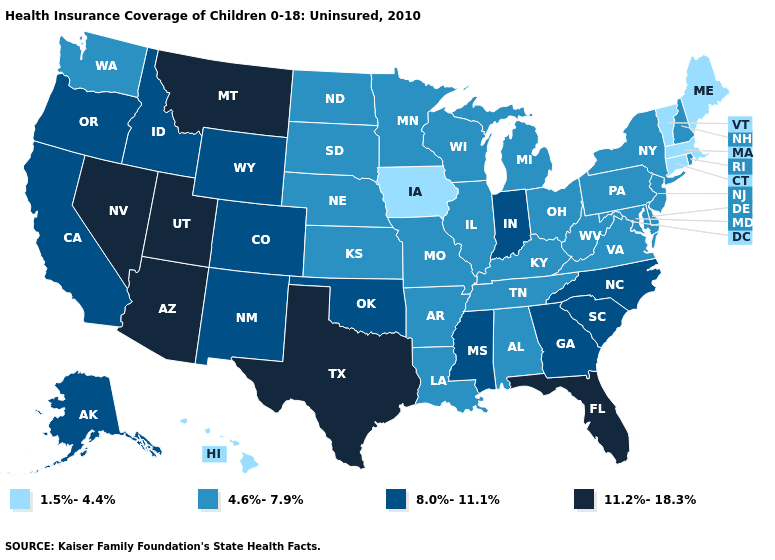Among the states that border Idaho , which have the highest value?
Be succinct. Montana, Nevada, Utah. What is the lowest value in the USA?
Keep it brief. 1.5%-4.4%. Which states have the lowest value in the MidWest?
Keep it brief. Iowa. How many symbols are there in the legend?
Be succinct. 4. Which states have the highest value in the USA?
Short answer required. Arizona, Florida, Montana, Nevada, Texas, Utah. What is the lowest value in states that border Missouri?
Concise answer only. 1.5%-4.4%. What is the value of Arkansas?
Write a very short answer. 4.6%-7.9%. What is the value of Tennessee?
Answer briefly. 4.6%-7.9%. Among the states that border Idaho , which have the lowest value?
Quick response, please. Washington. Among the states that border Missouri , which have the lowest value?
Short answer required. Iowa. Name the states that have a value in the range 11.2%-18.3%?
Give a very brief answer. Arizona, Florida, Montana, Nevada, Texas, Utah. Does Oregon have the highest value in the West?
Quick response, please. No. What is the highest value in the USA?
Be succinct. 11.2%-18.3%. Among the states that border Georgia , does Florida have the highest value?
Short answer required. Yes. What is the value of Missouri?
Write a very short answer. 4.6%-7.9%. 